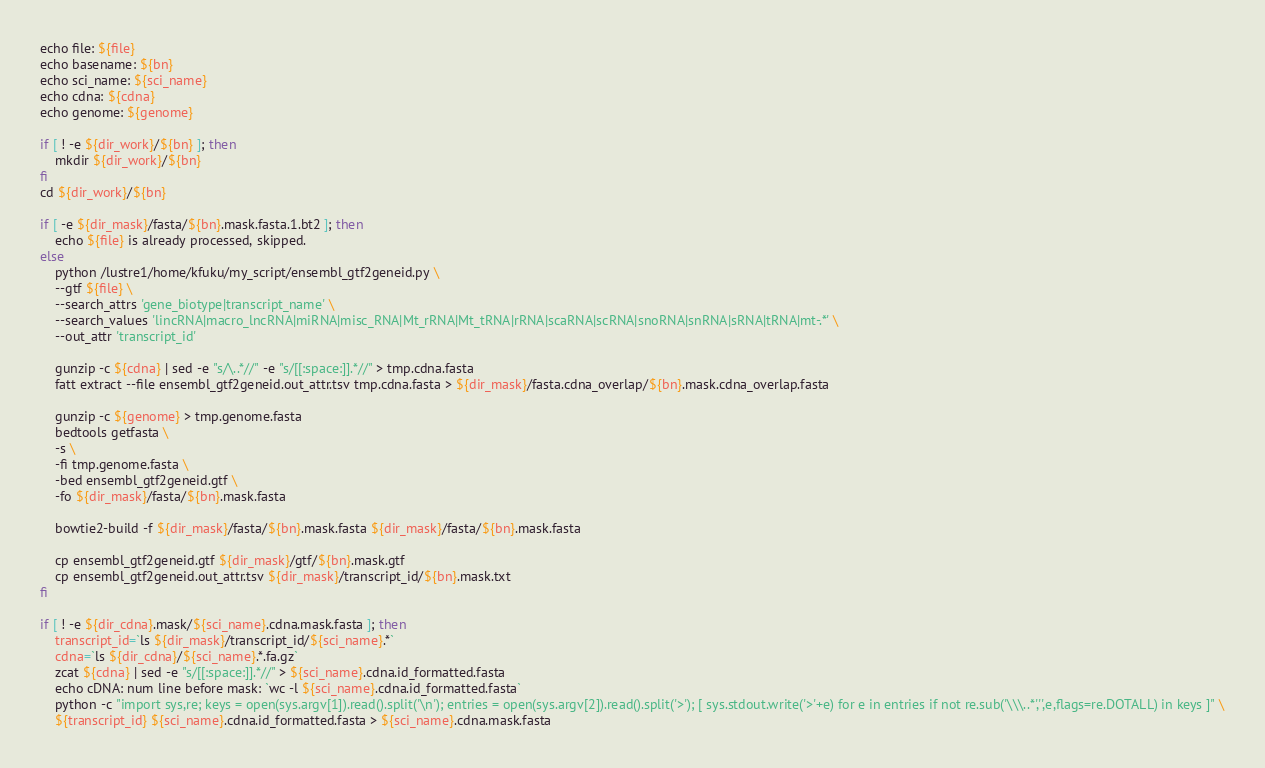Convert code to text. <code><loc_0><loc_0><loc_500><loc_500><_Bash_>echo file: ${file}
echo basename: ${bn}
echo sci_name: ${sci_name}
echo cdna: ${cdna}
echo genome: ${genome}

if [ ! -e ${dir_work}/${bn} ]; then
	mkdir ${dir_work}/${bn}
fi
cd ${dir_work}/${bn}

if [ -e ${dir_mask}/fasta/${bn}.mask.fasta.1.bt2 ]; then
	echo ${file} is already processed, skipped.
else	
	python /lustre1/home/kfuku/my_script/ensembl_gtf2geneid.py \
	--gtf ${file} \
	--search_attrs 'gene_biotype|transcript_name' \
	--search_values 'lincRNA|macro_lncRNA|miRNA|misc_RNA|Mt_rRNA|Mt_tRNA|rRNA|scaRNA|scRNA|snoRNA|snRNA|sRNA|tRNA|mt-.*' \
	--out_attr 'transcript_id'

	gunzip -c ${cdna} | sed -e "s/\..*//" -e "s/[[:space:]].*//" > tmp.cdna.fasta
	fatt extract --file ensembl_gtf2geneid.out_attr.tsv tmp.cdna.fasta > ${dir_mask}/fasta.cdna_overlap/${bn}.mask.cdna_overlap.fasta

	gunzip -c ${genome} > tmp.genome.fasta
	bedtools getfasta \
	-s \
	-fi tmp.genome.fasta \
	-bed ensembl_gtf2geneid.gtf \
	-fo ${dir_mask}/fasta/${bn}.mask.fasta

	bowtie2-build -f ${dir_mask}/fasta/${bn}.mask.fasta ${dir_mask}/fasta/${bn}.mask.fasta

	cp ensembl_gtf2geneid.gtf ${dir_mask}/gtf/${bn}.mask.gtf
	cp ensembl_gtf2geneid.out_attr.tsv ${dir_mask}/transcript_id/${bn}.mask.txt
fi

if [ ! -e ${dir_cdna}.mask/${sci_name}.cdna.mask.fasta ]; then
	transcript_id=`ls ${dir_mask}/transcript_id/${sci_name}.*`
	cdna=`ls ${dir_cdna}/${sci_name}.*.fa.gz`
	zcat ${cdna} | sed -e "s/[[:space:]].*//" > ${sci_name}.cdna.id_formatted.fasta
	echo cDNA: num line before mask: `wc -l ${sci_name}.cdna.id_formatted.fasta`
	python -c "import sys,re; keys = open(sys.argv[1]).read().split('\n'); entries = open(sys.argv[2]).read().split('>'); [ sys.stdout.write('>'+e) for e in entries if not re.sub('\\\..*','',e,flags=re.DOTALL) in keys ]" \
	${transcript_id} ${sci_name}.cdna.id_formatted.fasta > ${sci_name}.cdna.mask.fasta</code> 